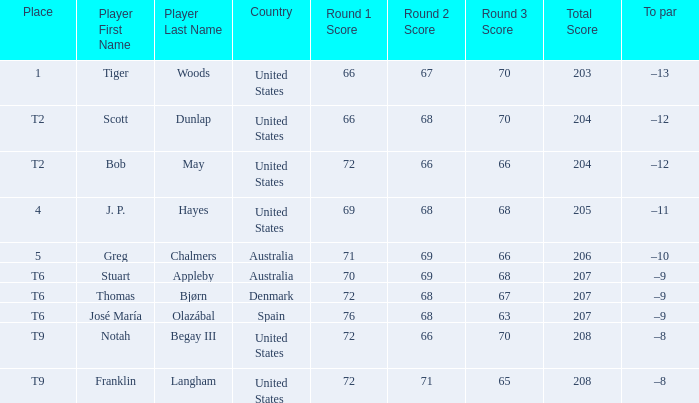What is the country of the player with a t6 place? Australia, Denmark, Spain. 